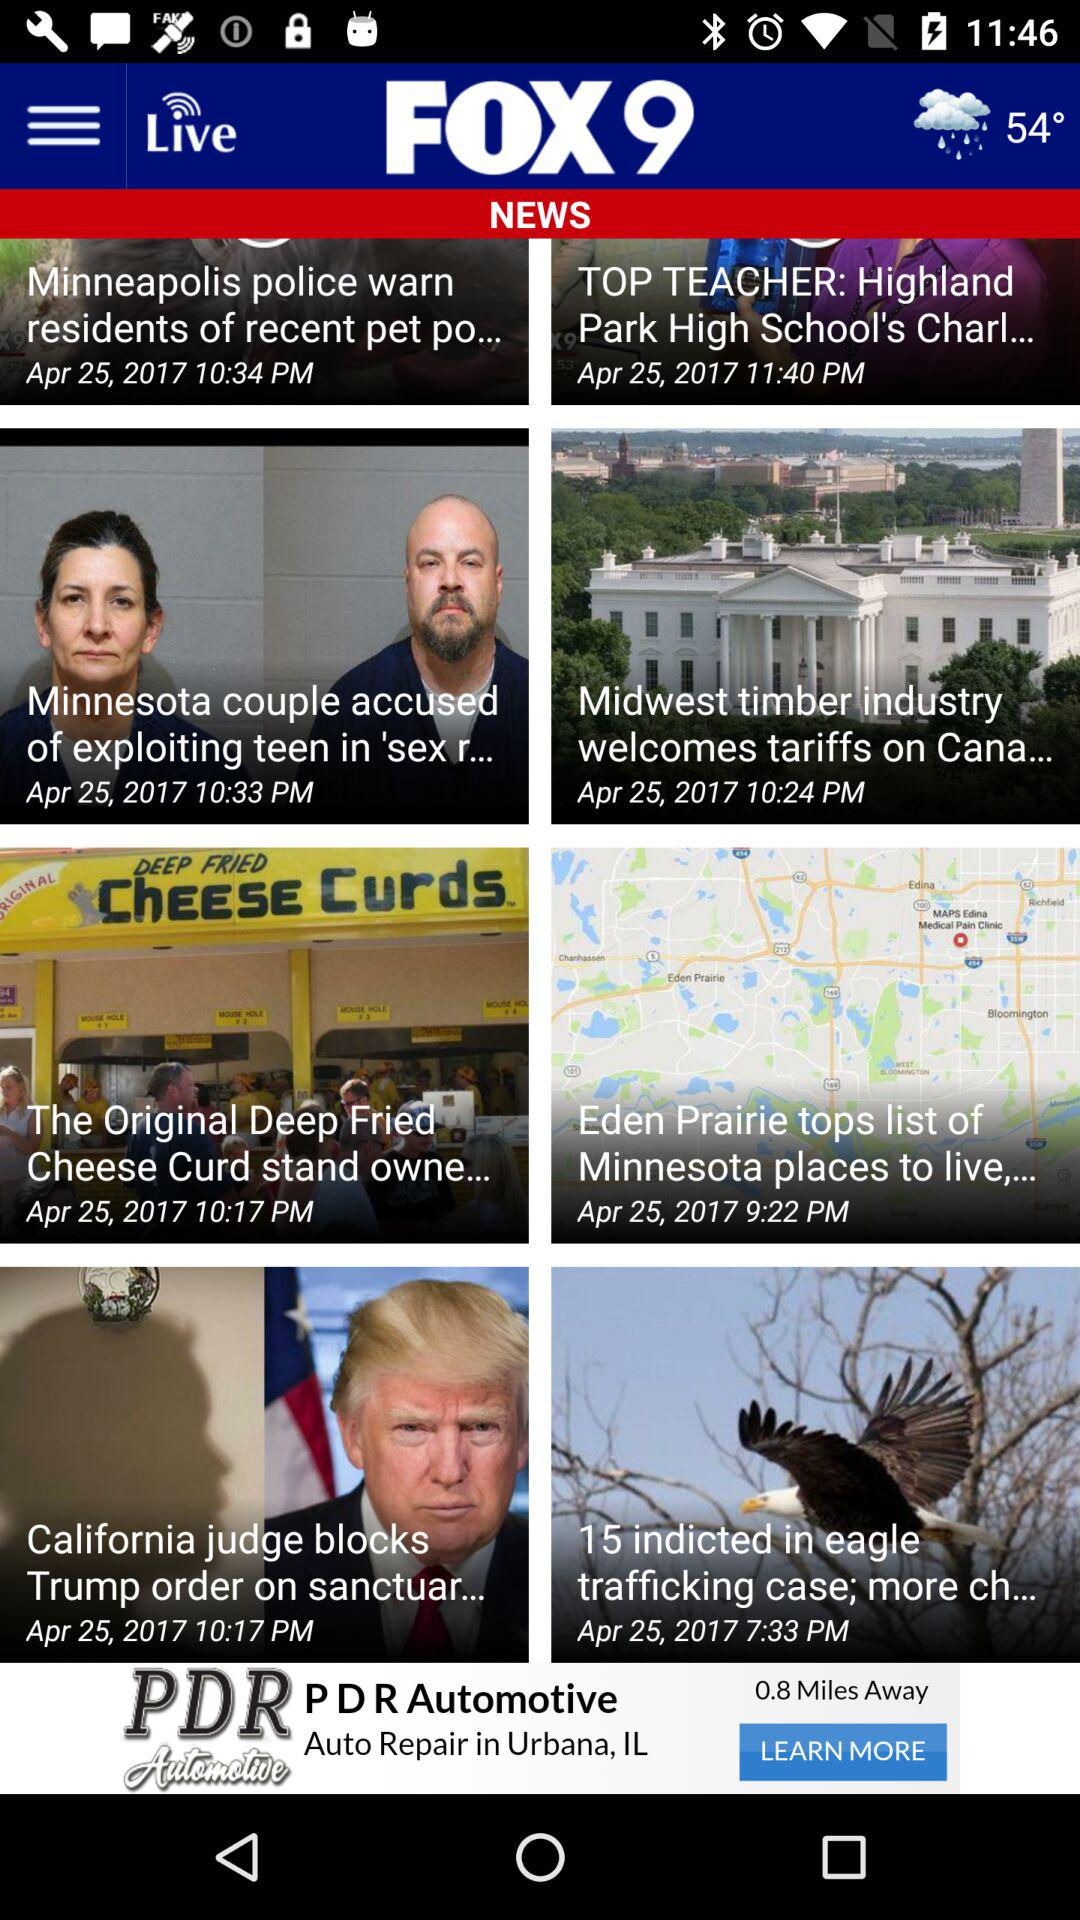What are the weather and temperature shown on the screen? The weather is rainy and the temperature is 54 degrees. 